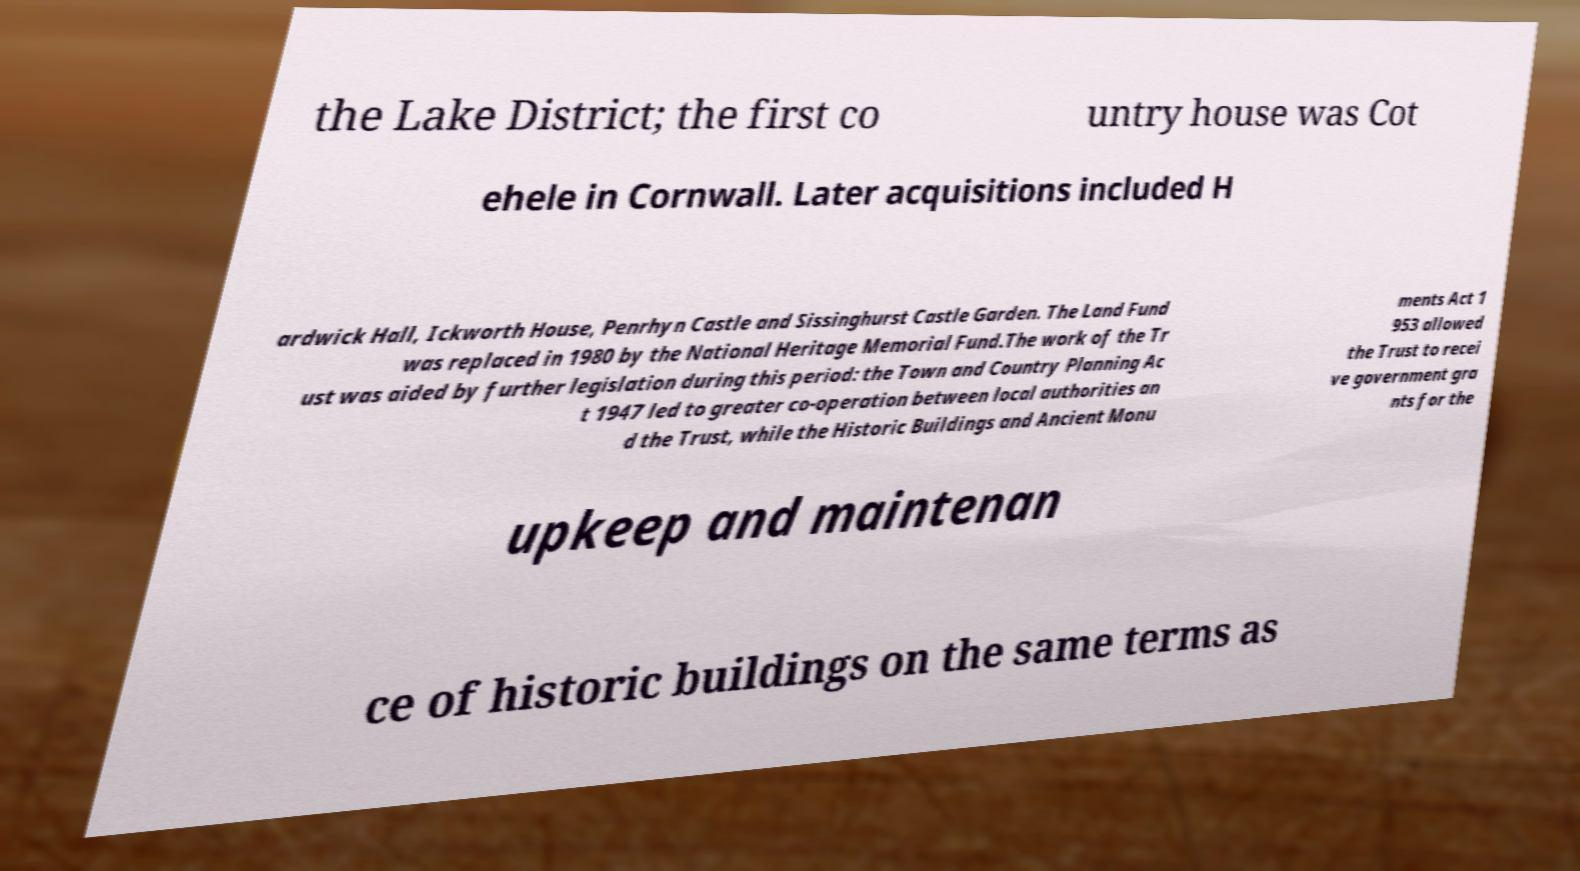For documentation purposes, I need the text within this image transcribed. Could you provide that? the Lake District; the first co untry house was Cot ehele in Cornwall. Later acquisitions included H ardwick Hall, Ickworth House, Penrhyn Castle and Sissinghurst Castle Garden. The Land Fund was replaced in 1980 by the National Heritage Memorial Fund.The work of the Tr ust was aided by further legislation during this period: the Town and Country Planning Ac t 1947 led to greater co-operation between local authorities an d the Trust, while the Historic Buildings and Ancient Monu ments Act 1 953 allowed the Trust to recei ve government gra nts for the upkeep and maintenan ce of historic buildings on the same terms as 